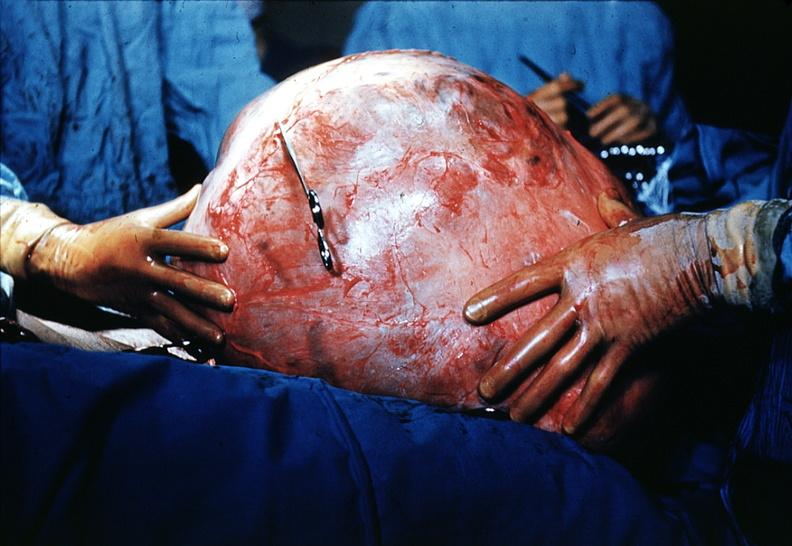where does this belong to?
Answer the question using a single word or phrase. Female reproductive system 